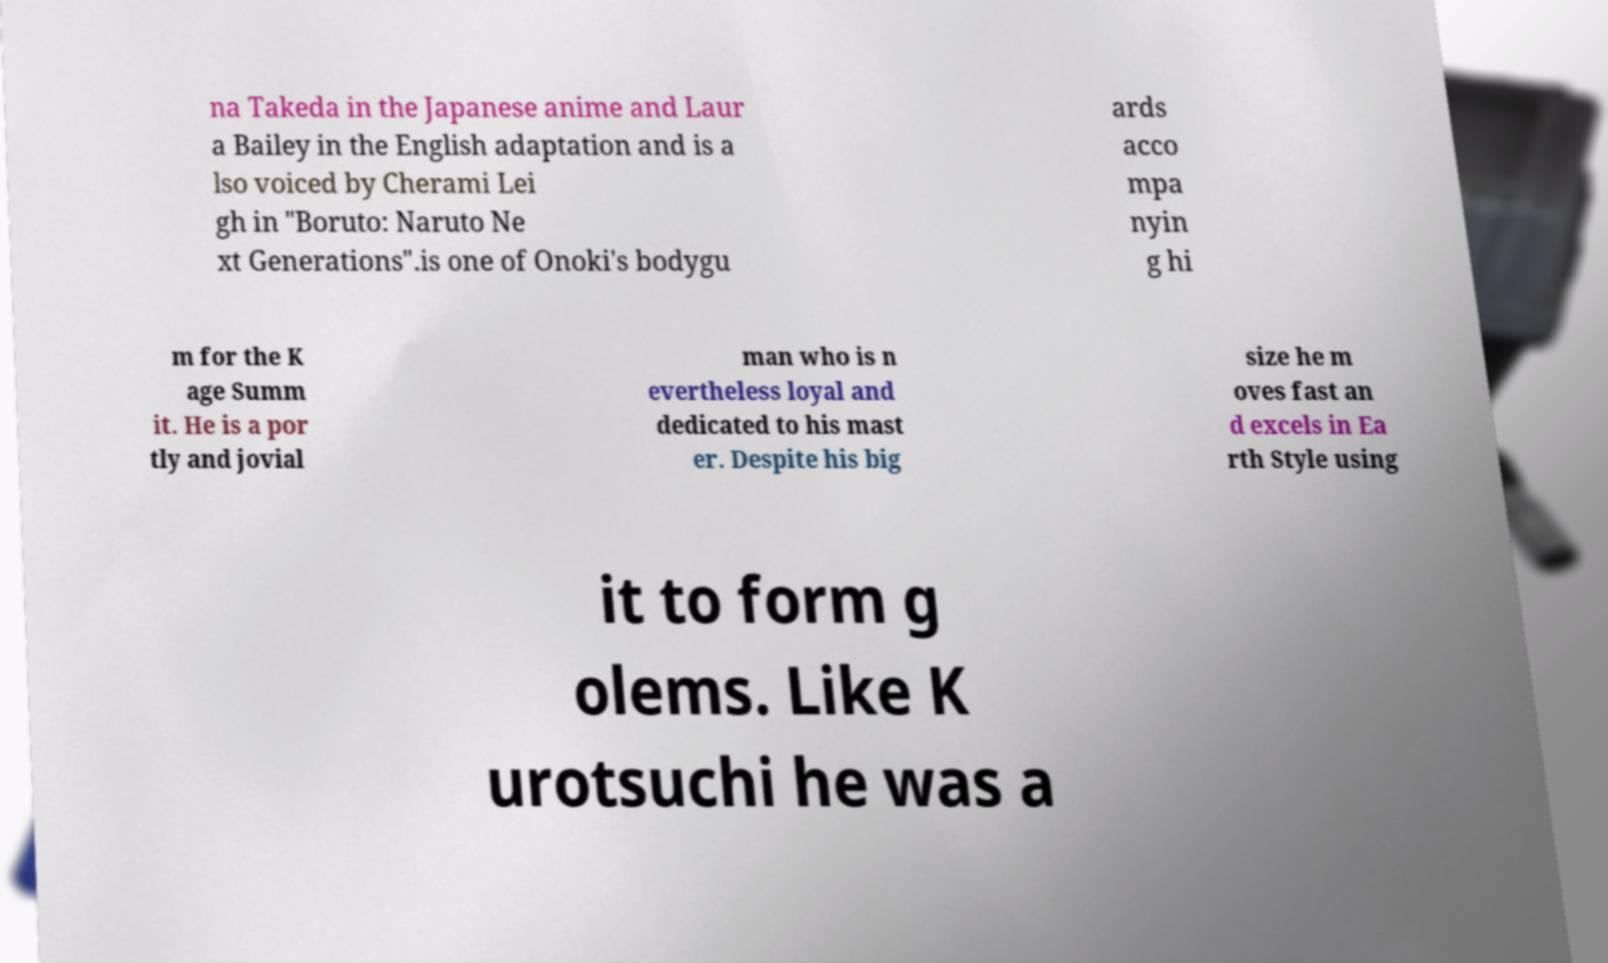Please read and relay the text visible in this image. What does it say? na Takeda in the Japanese anime and Laur a Bailey in the English adaptation and is a lso voiced by Cherami Lei gh in "Boruto: Naruto Ne xt Generations".is one of Onoki's bodygu ards acco mpa nyin g hi m for the K age Summ it. He is a por tly and jovial man who is n evertheless loyal and dedicated to his mast er. Despite his big size he m oves fast an d excels in Ea rth Style using it to form g olems. Like K urotsuchi he was a 